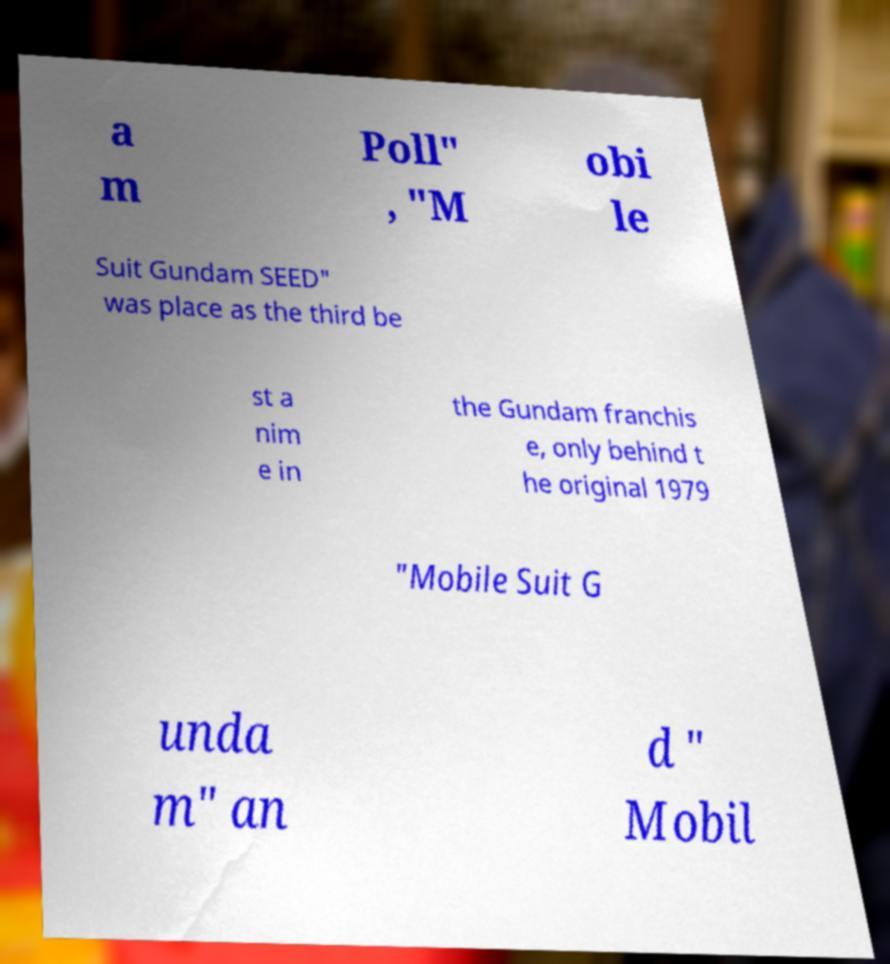Can you accurately transcribe the text from the provided image for me? a m Poll" , "M obi le Suit Gundam SEED" was place as the third be st a nim e in the Gundam franchis e, only behind t he original 1979 "Mobile Suit G unda m" an d " Mobil 